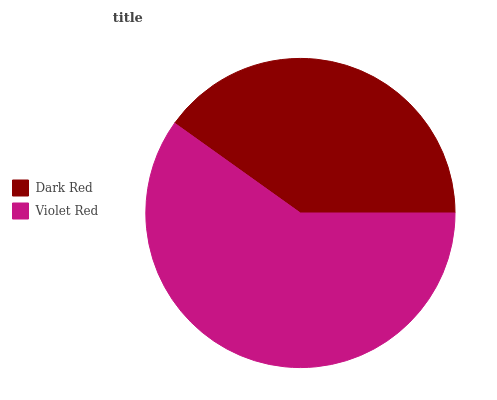Is Dark Red the minimum?
Answer yes or no. Yes. Is Violet Red the maximum?
Answer yes or no. Yes. Is Violet Red the minimum?
Answer yes or no. No. Is Violet Red greater than Dark Red?
Answer yes or no. Yes. Is Dark Red less than Violet Red?
Answer yes or no. Yes. Is Dark Red greater than Violet Red?
Answer yes or no. No. Is Violet Red less than Dark Red?
Answer yes or no. No. Is Violet Red the high median?
Answer yes or no. Yes. Is Dark Red the low median?
Answer yes or no. Yes. Is Dark Red the high median?
Answer yes or no. No. Is Violet Red the low median?
Answer yes or no. No. 